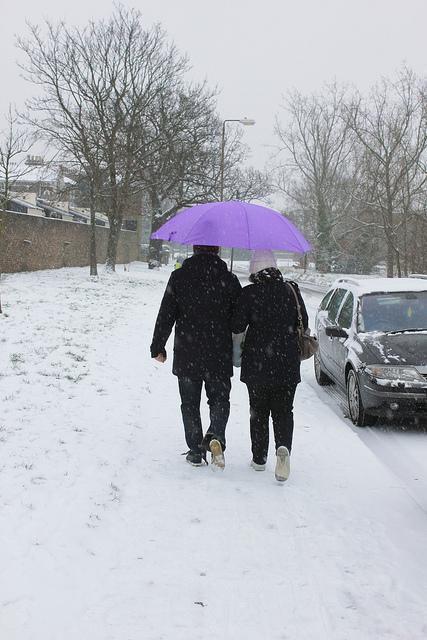How many people can you see?
Give a very brief answer. 2. 